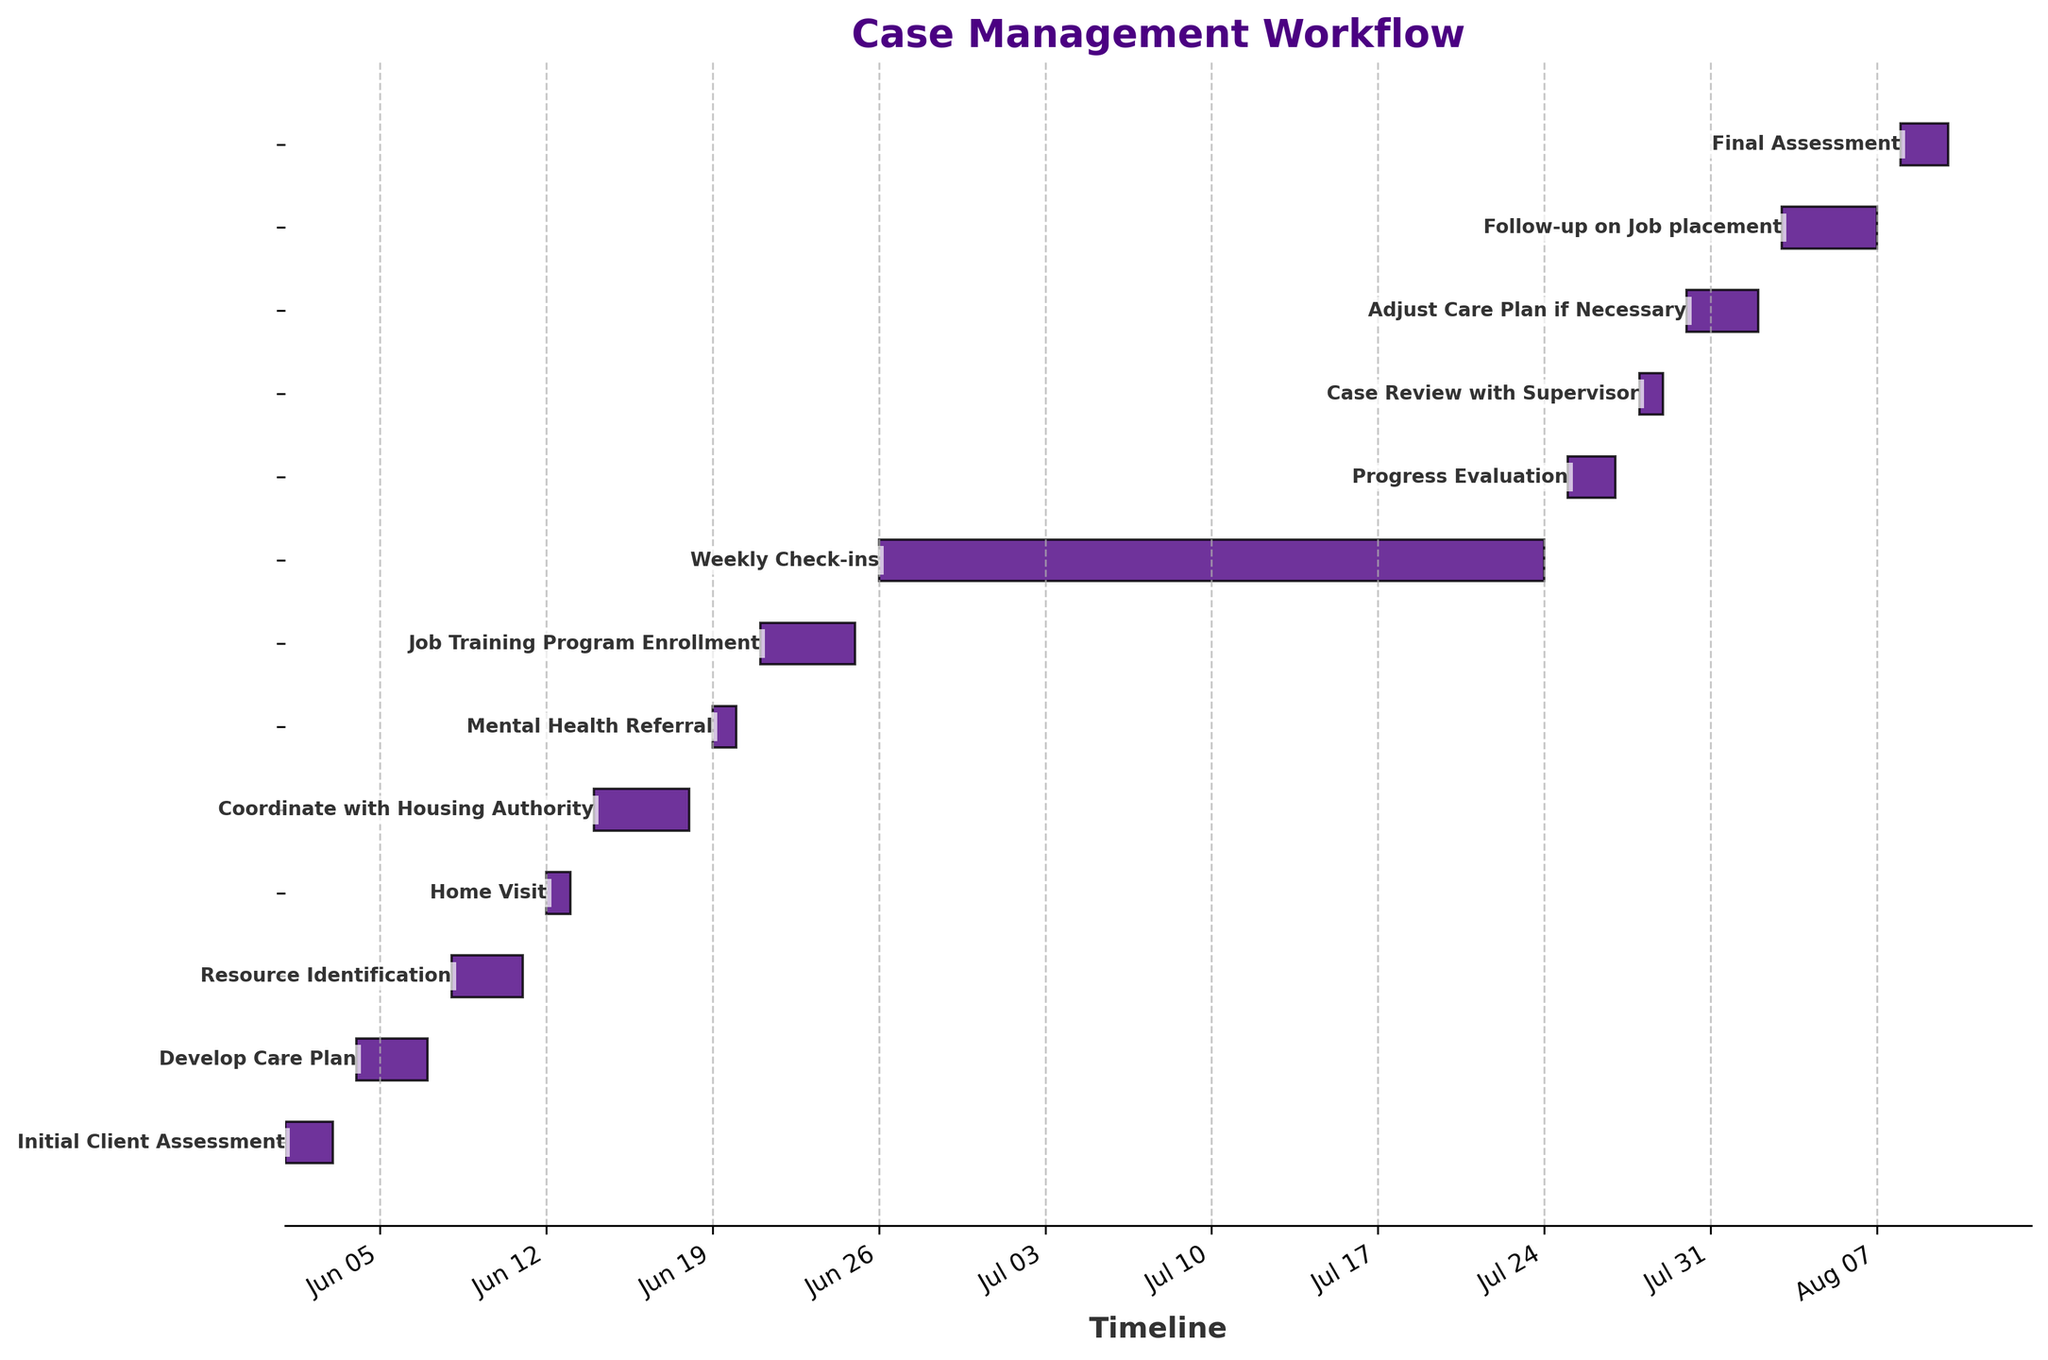What is the title of the chart? The title is typically placed at the top of the chart and is clearly visible. In this Gantt chart, the title reads "Case Management Workflow."
Answer: Case Management Workflow How many tasks are listed in the workflow? Count each task listed on the horizontal bars on the y-axis. By counting them, you see there are 13 tasks.
Answer: 13 What is the duration of the "Job Training Program Enrollment" task? Find the "Job Training Program Enrollment" task and check the length of the horizontal bar representing it. According to the data, it lasts from June 21 to June 25, which is 5 days.
Answer: 5 days Which task starts immediately after "Coordinate with Housing Authority"? Check the end date of "Coordinate with Housing Authority" and see which task starts the day after that. The "Coordinate with Housing Authority" task ends on June 18, and the "Mental Health Referral" starts on June 19.
Answer: Mental Health Referral How long does the entire workflow take from the start of the first task to the end of the last task? Identify the start date of the first task (June 1) and the end date of the last task (August 10), and calculate the difference between these dates. This adds up to 71 days.
Answer: 71 days Which task has the longest duration? Compare the lengths of the bars representing each task. "Weekly Check-ins" spans from June 26 to July 24, making it the longest at 29 days.
Answer: Weekly Check-ins What is the duration difference between "Initial Client Assessment" and "Progress Evaluation"? Calculate the duration of "Initial Client Assessment" (3 days) and "Progress Evaluation" (3 days) and find the difference. Both tasks have the same duration, so the difference is 0 days.
Answer: 0 days Which tasks are shorter than the "Home Visit" in duration? Determine the duration of "Home Visit" (2 days) and compare it to other tasks. "Mental Health Referral," "Case Review with Supervisor," and "Final Assessment" also have 2-day durations. Since the question asks for shorter tasks, there are no tasks shorter than "Home Visit."
Answer: None Which tasks overlap with the "Develop Care Plan" task? "Develop Care Plan" runs from June 4 to June 7. Check for tasks that have start or end dates within this range. No tasks overlap with "Develop Care Plan" directly in this chart.
Answer: None How many tasks are there after "Progress Evaluation"? Find the "Progress Evaluation" task and count the tasks listed after it. There are 3 tasks following "Progress Evaluation": "Case Review with Supervisor," "Adjust Care Plan if Necessary," and "Follow-up on Job placement."
Answer: 3 tasks 